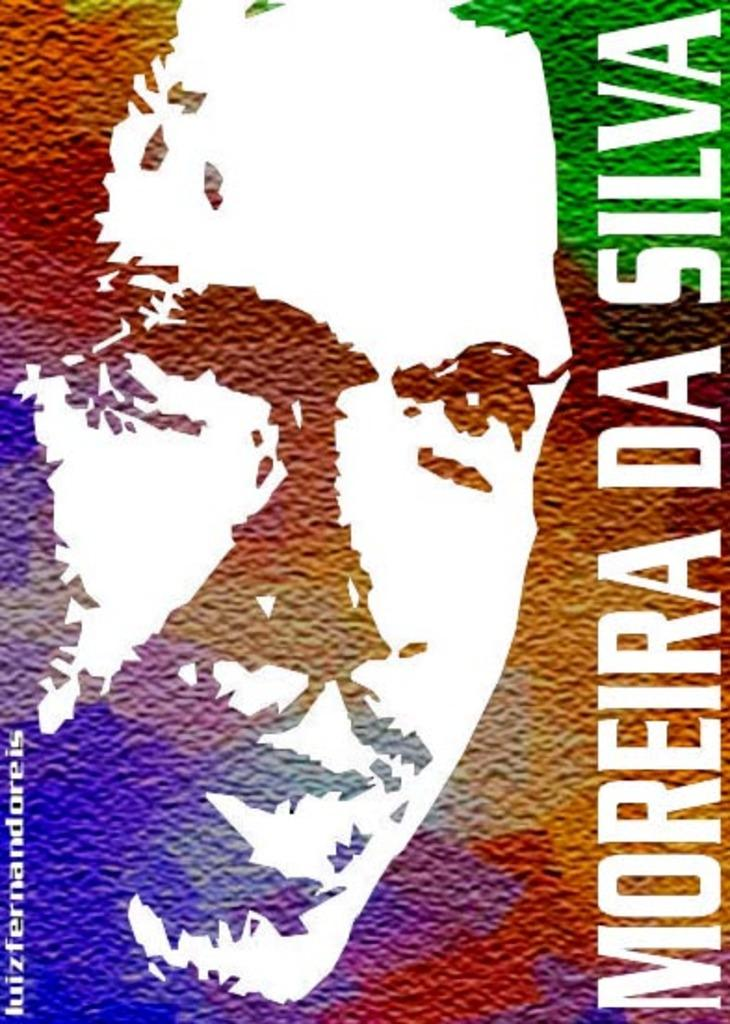<image>
Give a short and clear explanation of the subsequent image. A poster for Moreira Da Silva with his portrait. 